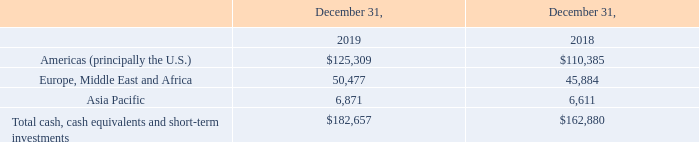Liquidity
Cash and Liquidity. As of December 31, 2019, our principal sources of liquidity included cash, cash equivalents, and short-term investments of $182.7 million, compared to $162.9 million as of December 31, 2018. We generally invest our excess cash balances in low-risk, short-term investments to limit our exposure to market and credit risks.
During the first quarter of 2018, we refinanced our 2015 Credit Agreement which extended the term of the loan to March 2023 as well as obtained a reduction in the interest rate and other fees. The 2018 Credit Agreement increased our liquidity and capital resources position by approximately $30 million.
As part of our 2018 Credit Agreement, we have a $200 million senior secured revolving loan facility with a syndicate of financial institutions that expires in March 2023. As of December 31, 2019, there were no borrowings outstanding on the 2018 Revolver. The 2018 Credit Agreement contains customary affirmative covenants and financial covenants. As of December 31, 2019, and the date of this filing, we believe that we are in compliance with the provisions of the 2018 Credit Agreement.
Our cash, cash equivalents, and short-term investment balances as of the end of the indicated periods were located in the following geographical regions (in thousands):
We generally have ready access to substantially all of our cash, cash equivalents, and short-term investment balances, but may face limitations on moving cash out of certain foreign jurisdictions due to currency controls and potential negative economic consequences. As of December 31, 2019, we had $2.7 million of cash restricted as to use to collateralize outstanding letters of credit.
Cash Flows From Operating Activities. We calculate our cash flows from operating activities beginning with net income, adding back the impact of non-cash items or nonoperating activity (e.g., depreciation, amortization, amortization of OID, impairments, gain/loss from debt extinguishments, deferred income taxes, stock-based compensation, etc.), and then factoring in the impact of changes in operating assets and liabilities.
Our primary source of cash is from our operating activities. Our current business model consists of a significant amount of recurring revenue sources related to our long-term cloud-based and managed services arrangements (mostly billed monthly), payment process transaction services (mostly billed monthly), and software maintenance agreements (billed monthly, quarterly, or annually). This recurring revenue base provides us with a reliable and predictable source of cash. In addition, software license fees and professional services revenues are sources of cash, but the payment streams for these items are less predictable.
The primary use of our cash is to fund our operating activities. Over half of our total operating costs relate to labor costs (both employees and contracted labor) for the following: (i) compensation; (ii) related fringe benefits; and (iii) reimbursements for travel and entertainment expenses. The other primary cash requirements for our operating expenses consist of: (i) computing capacity and related services and communication lines for our outsourced cloud-based business; (ii) paper, envelopes, and related supplies for our statement processing solutions; (iii) transaction fees paid in conjunction with the delivery of services under our payment services contracts; (iv) hardware and software; and (v) rent and related facility costs. These items are purchased under a variety of both short-term and long-term contractual commitments. A summary of our material contractual obligations is provided below.
What is the company's total cash, cash equivalents and short-term investments in 2019?
Answer scale should be: million. $182.7. What is the company's total cash, cash equivalents and short-term investments in 2018?
Answer scale should be: million. $162.9. What did the company do as part of its 2018 Credit Agreement? Refinanced our 2015 credit agreement which extended the term of the loan to march 2023 as well as obtained a reduction in the interest rate and other fees. What is the company's total cash, cash equivalents and short-term investments in both 2018 and 2019? $182.7 + $162.9 
Answer: 345.6. What proportion of the company's cash, cash equivalents and short-term investments in 2019 are from the Asia Pacific region?
Answer scale should be: percent. 6,871/182,657 
Answer: 3.76. What is the total company's cash, cash equivalents, and short-term investment earned from the American region and the Europe, Middle East and Africa region in 2019?
Answer scale should be: thousand. $50,477+$125,309 
Answer: 175786. 